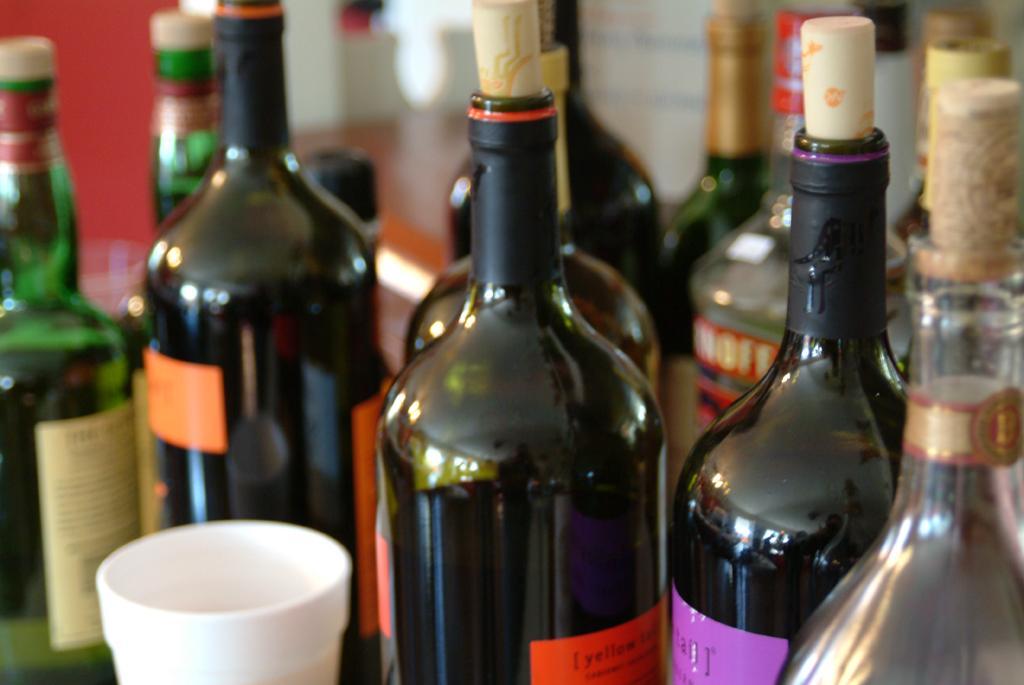Can you describe this image briefly? In this picture there are many wine bottle placed on a table 